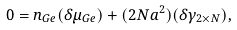<formula> <loc_0><loc_0><loc_500><loc_500>0 = n _ { G e } ( \delta \mu _ { G e } ) + ( 2 N a ^ { 2 } ) ( \delta \gamma _ { 2 \times N } ) ,</formula> 